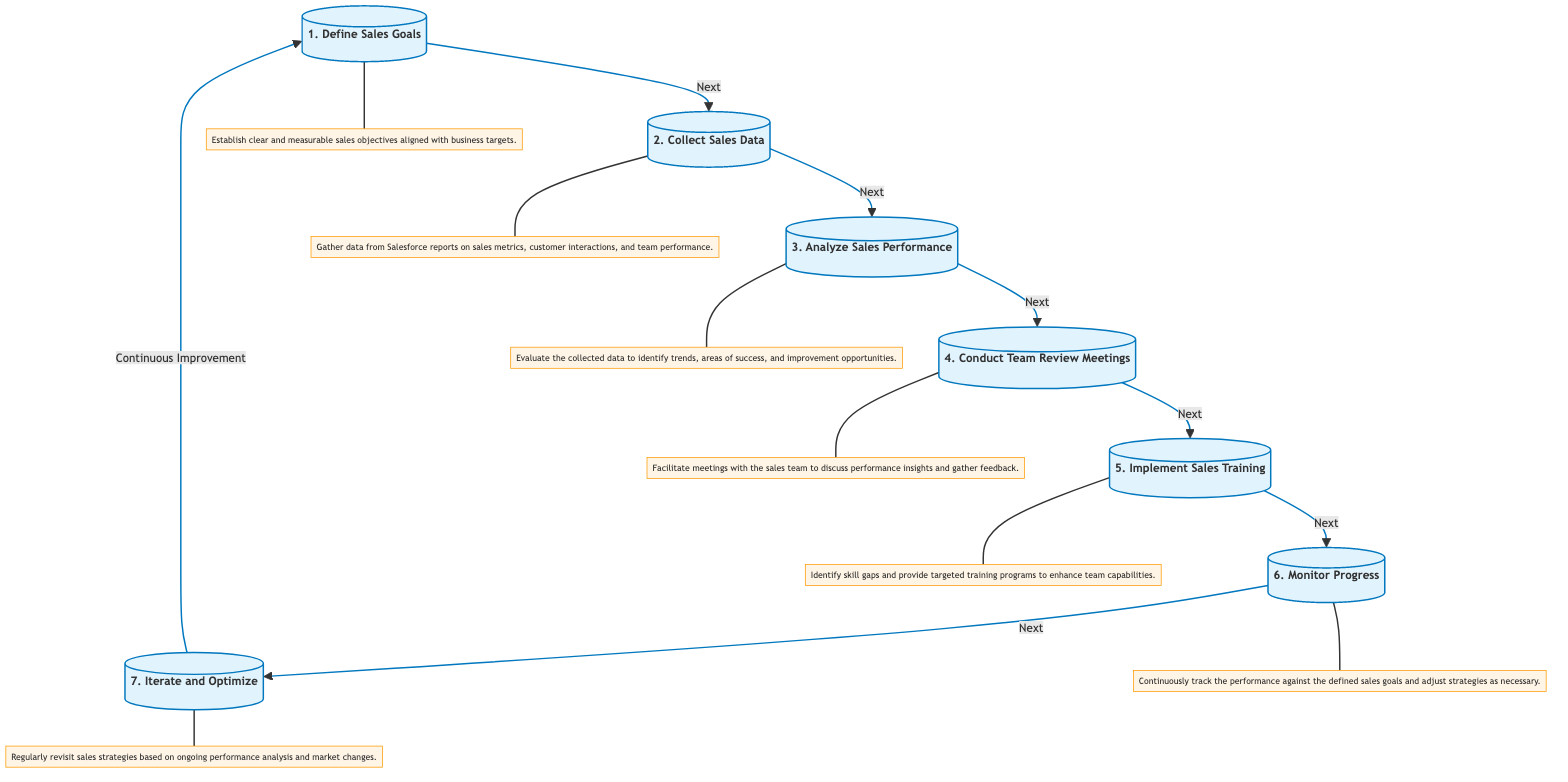What is the first step in the sales performance review cycle? The first step in the diagram is labeled as "1. Define Sales Goals." This is identified as the starting point of the flowchart, making it clear it is the initial action in the cycle.
Answer: Define Sales Goals How many total steps are there in the sales performance review cycle? The flowchart shows a total of seven distinct steps, each leading to the next, ultimately creating a complete cycle of sales performance review.
Answer: Seven Which step follows "Analyze Sales Performance"? According to the flowchart, after "Analyze Sales Performance," the next step is "Conduct Team Review Meetings." This means these two steps are sequentially linked in the cycle.
Answer: Conduct Team Review Meetings What is the key purpose of the step "Implement Sales Training"? The description under this step states, "Identify skill gaps and provide targeted training programs to enhance team capabilities." This indicates that the focus is on improving the skills within the team.
Answer: Enhance team capabilities What does the "Monitor Progress" step aim to achieve? The explanatory text for this step indicates that it aims to "Continuously track the performance against the defined sales goals and adjust strategies as necessary." This demonstrates a feedback loop to ensure continuous improvement.
Answer: Adjust strategies What is the relationship between the steps "Collect Sales Data" and "Analyze Sales Performance"? The flowchart connects these two steps directly, showing that after sales data is collected, it is essential to analyze that data. This establishes a dependency where analysis cannot occur without data collection.
Answer: Directly connected Which step involves gathering feedback from the sales team? The step specifically described as "Conduct Team Review Meetings" involves the facilitation of meetings where performance insights are discussed and feedback is collected from the sales team.
Answer: Conduct Team Review Meetings In what way does the cycle allow for continuous improvement? The diagram clearly illustrates a loop from the last step, "Iterate and Optimize," back to the first step, "Define Sales Goals." This circular flow implies that feedback and analysis inform future goal setting, promoting continuous improvement.
Answer: Continuous improvement 